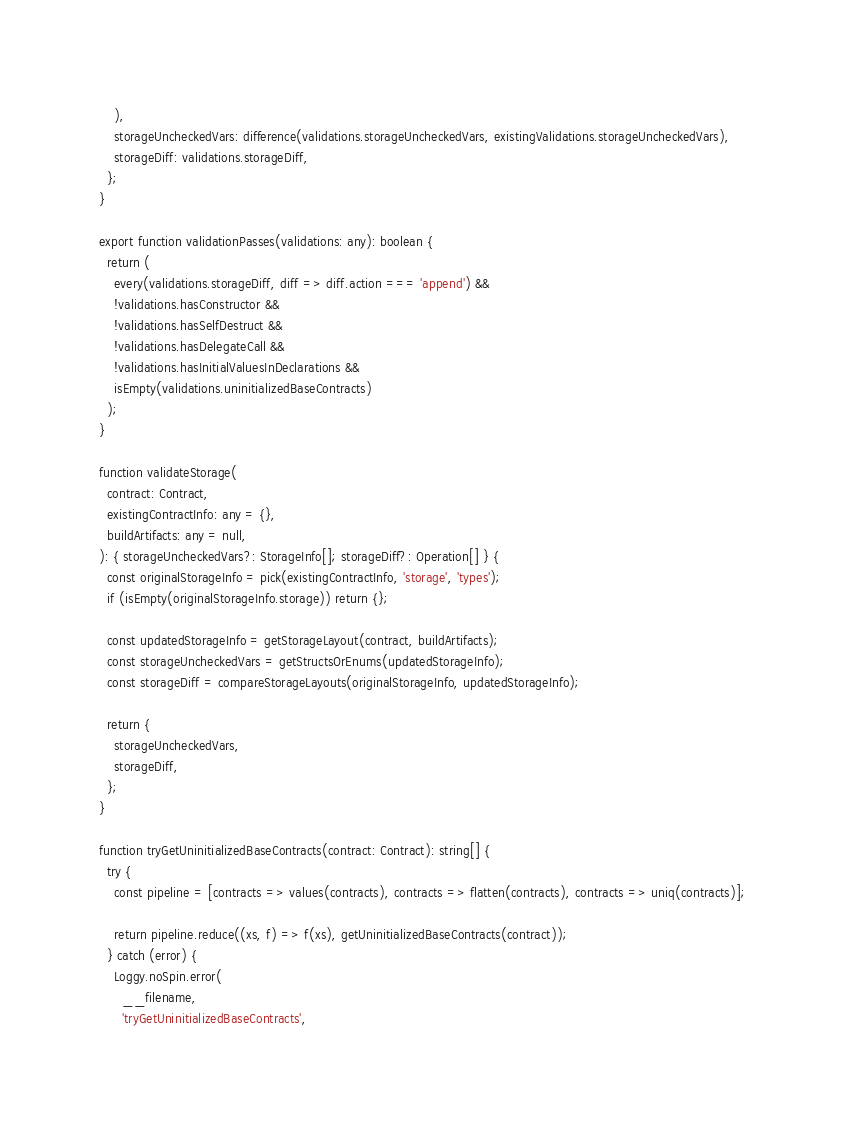Convert code to text. <code><loc_0><loc_0><loc_500><loc_500><_TypeScript_>    ),
    storageUncheckedVars: difference(validations.storageUncheckedVars, existingValidations.storageUncheckedVars),
    storageDiff: validations.storageDiff,
  };
}

export function validationPasses(validations: any): boolean {
  return (
    every(validations.storageDiff, diff => diff.action === 'append') &&
    !validations.hasConstructor &&
    !validations.hasSelfDestruct &&
    !validations.hasDelegateCall &&
    !validations.hasInitialValuesInDeclarations &&
    isEmpty(validations.uninitializedBaseContracts)
  );
}

function validateStorage(
  contract: Contract,
  existingContractInfo: any = {},
  buildArtifacts: any = null,
): { storageUncheckedVars?: StorageInfo[]; storageDiff?: Operation[] } {
  const originalStorageInfo = pick(existingContractInfo, 'storage', 'types');
  if (isEmpty(originalStorageInfo.storage)) return {};

  const updatedStorageInfo = getStorageLayout(contract, buildArtifacts);
  const storageUncheckedVars = getStructsOrEnums(updatedStorageInfo);
  const storageDiff = compareStorageLayouts(originalStorageInfo, updatedStorageInfo);

  return {
    storageUncheckedVars,
    storageDiff,
  };
}

function tryGetUninitializedBaseContracts(contract: Contract): string[] {
  try {
    const pipeline = [contracts => values(contracts), contracts => flatten(contracts), contracts => uniq(contracts)];

    return pipeline.reduce((xs, f) => f(xs), getUninitializedBaseContracts(contract));
  } catch (error) {
    Loggy.noSpin.error(
      __filename,
      'tryGetUninitializedBaseContracts',</code> 